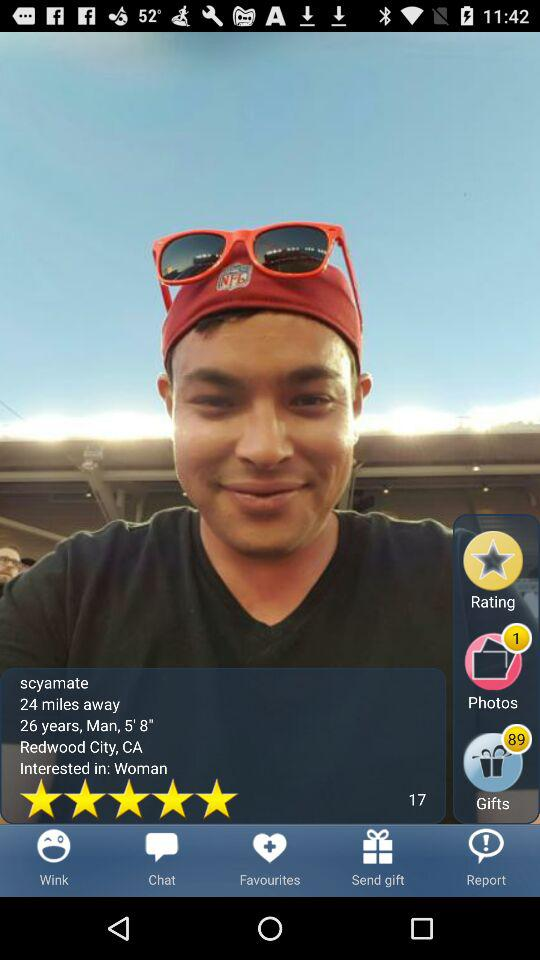In which gender is the Scyamate interested?
When the provided information is insufficient, respond with <no answer>. <no answer> 